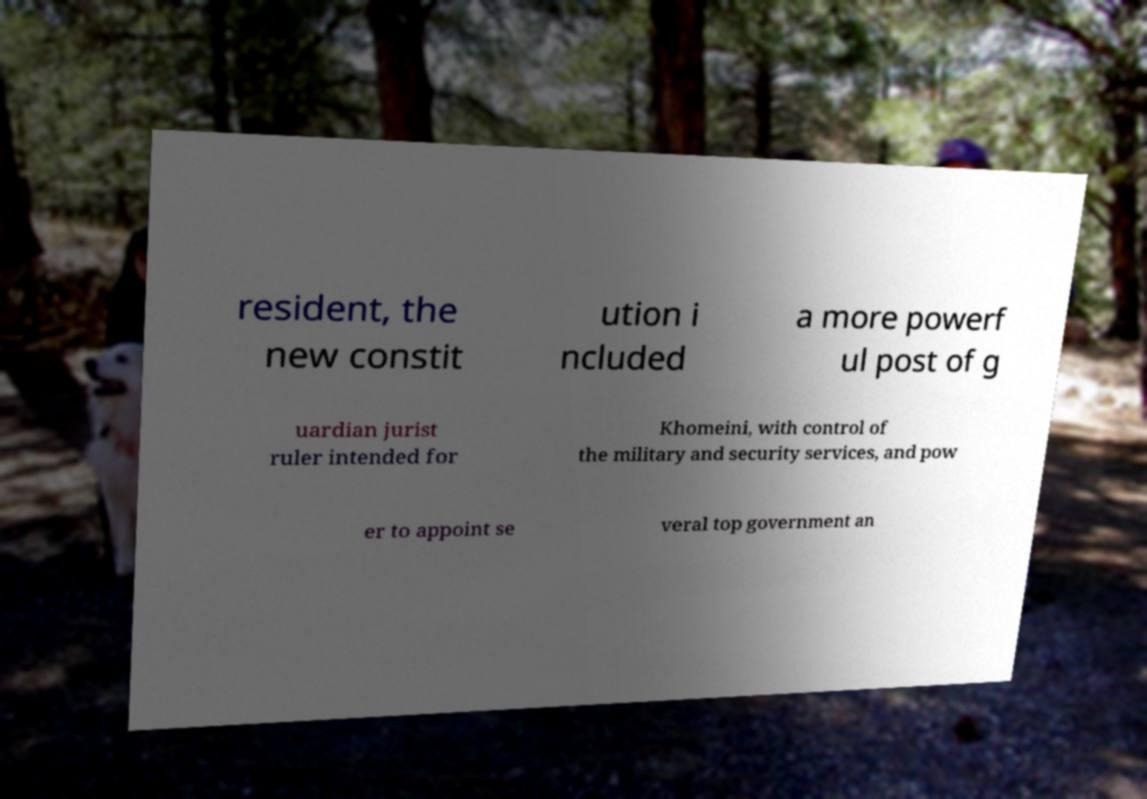Can you read and provide the text displayed in the image?This photo seems to have some interesting text. Can you extract and type it out for me? resident, the new constit ution i ncluded a more powerf ul post of g uardian jurist ruler intended for Khomeini, with control of the military and security services, and pow er to appoint se veral top government an 